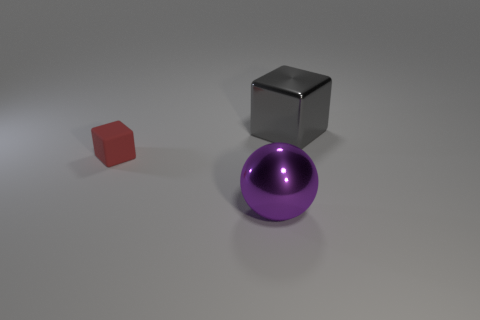Are there any other things that have the same material as the tiny object?
Offer a terse response. No. Is the number of purple objects right of the purple metal sphere less than the number of small cubes that are to the right of the tiny red matte cube?
Give a very brief answer. No. How many purple things are left of the large object right of the big metal object in front of the tiny red rubber object?
Offer a terse response. 1. There is another object that is the same shape as the small object; what size is it?
Provide a short and direct response. Large. Is there anything else that has the same size as the shiny ball?
Provide a short and direct response. Yes. Is the number of things that are behind the big block less than the number of large gray blocks?
Provide a succinct answer. Yes. Is the purple metal object the same shape as the gray metallic object?
Give a very brief answer. No. There is a small rubber thing that is the same shape as the big gray metallic thing; what is its color?
Ensure brevity in your answer.  Red. What number of large shiny cubes have the same color as the big sphere?
Keep it short and to the point. 0. How many objects are either blocks on the right side of the tiny matte thing or big red shiny cylinders?
Your response must be concise. 1. 